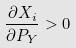<formula> <loc_0><loc_0><loc_500><loc_500>\frac { \partial X _ { i } } { \partial P _ { Y } } > 0</formula> 